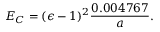<formula> <loc_0><loc_0><loc_500><loc_500>E _ { C } = ( \epsilon - 1 ) ^ { 2 } { \frac { 0 . 0 0 4 7 6 7 } { a } } .</formula> 